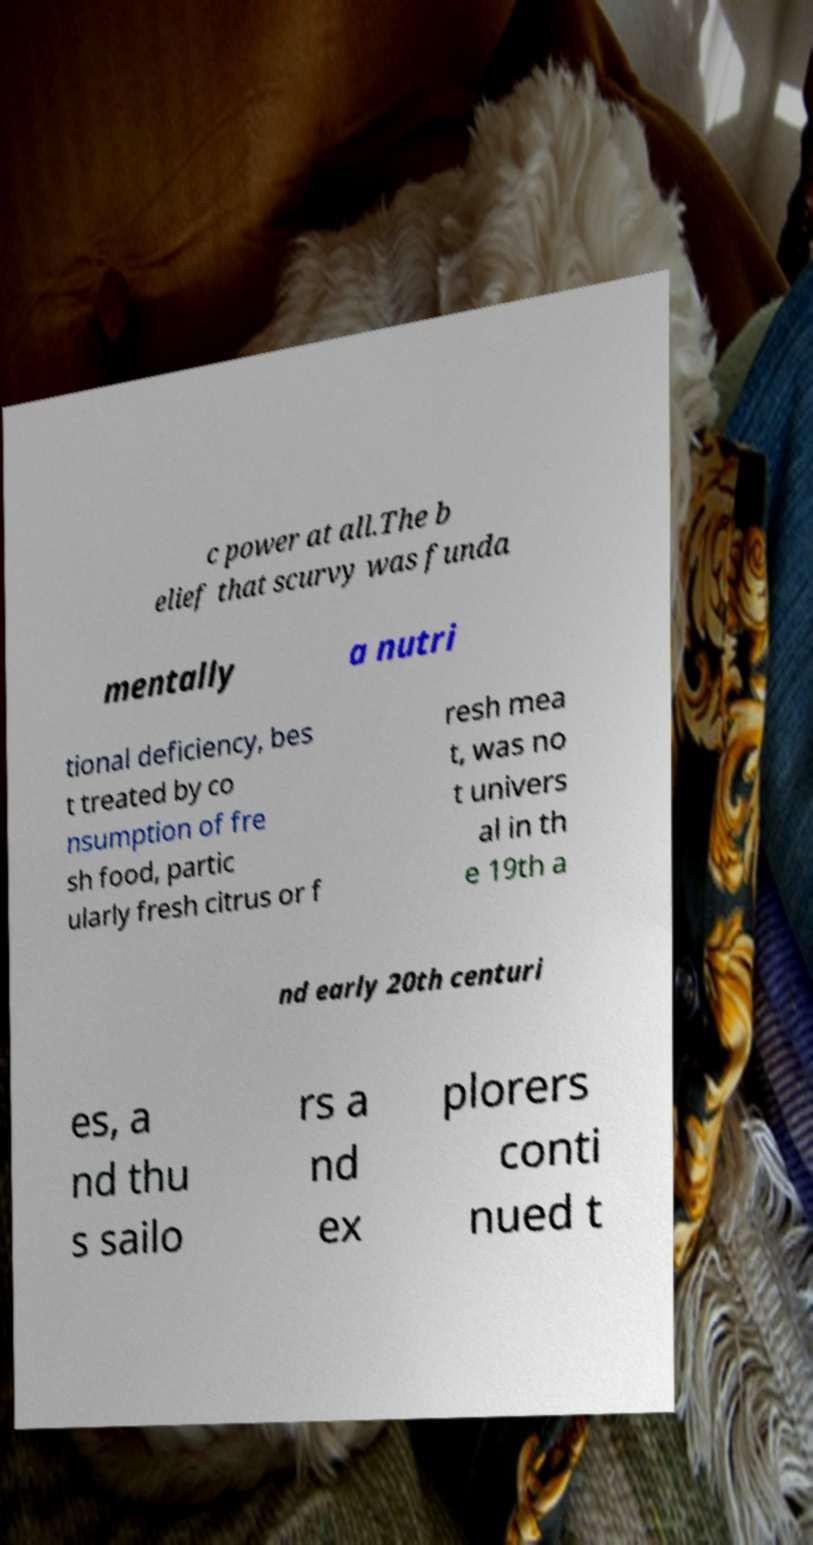For documentation purposes, I need the text within this image transcribed. Could you provide that? c power at all.The b elief that scurvy was funda mentally a nutri tional deficiency, bes t treated by co nsumption of fre sh food, partic ularly fresh citrus or f resh mea t, was no t univers al in th e 19th a nd early 20th centuri es, a nd thu s sailo rs a nd ex plorers conti nued t 